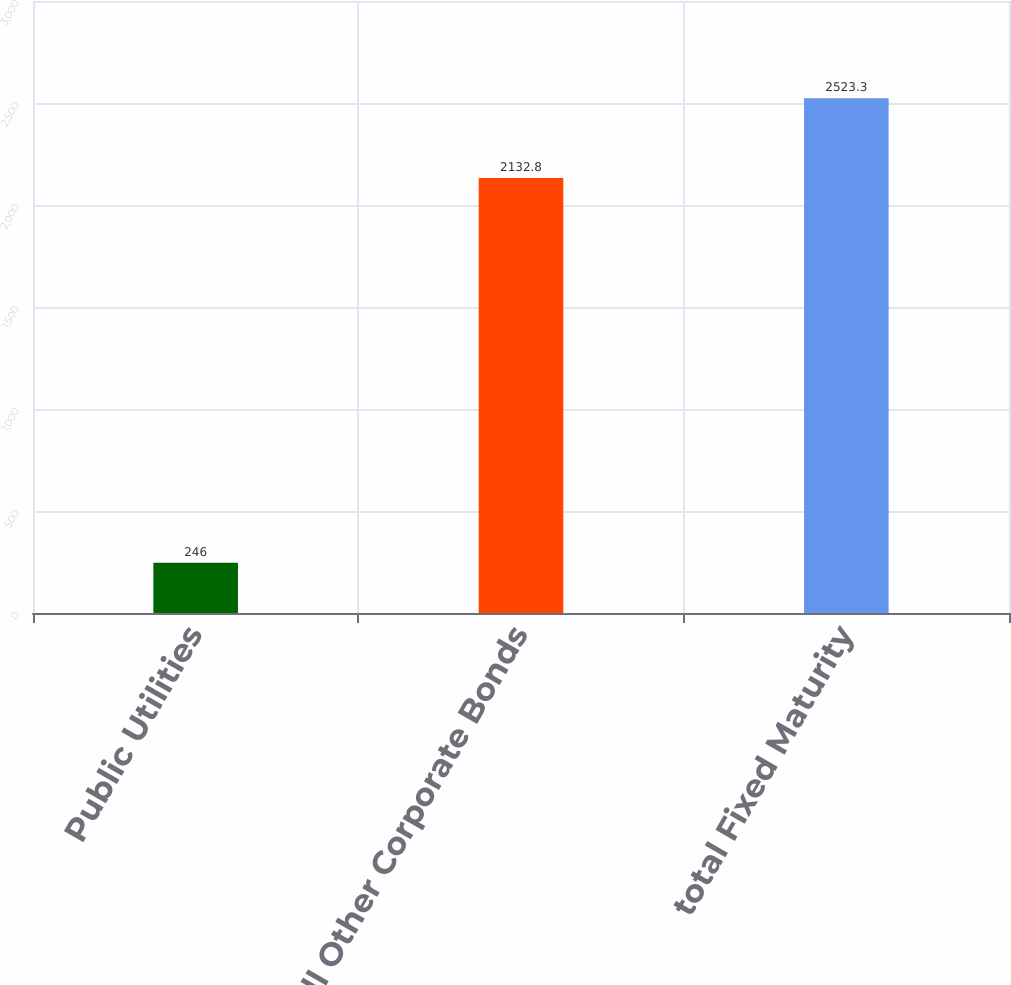<chart> <loc_0><loc_0><loc_500><loc_500><bar_chart><fcel>Public Utilities<fcel>All Other Corporate Bonds<fcel>total Fixed Maturity<nl><fcel>246<fcel>2132.8<fcel>2523.3<nl></chart> 